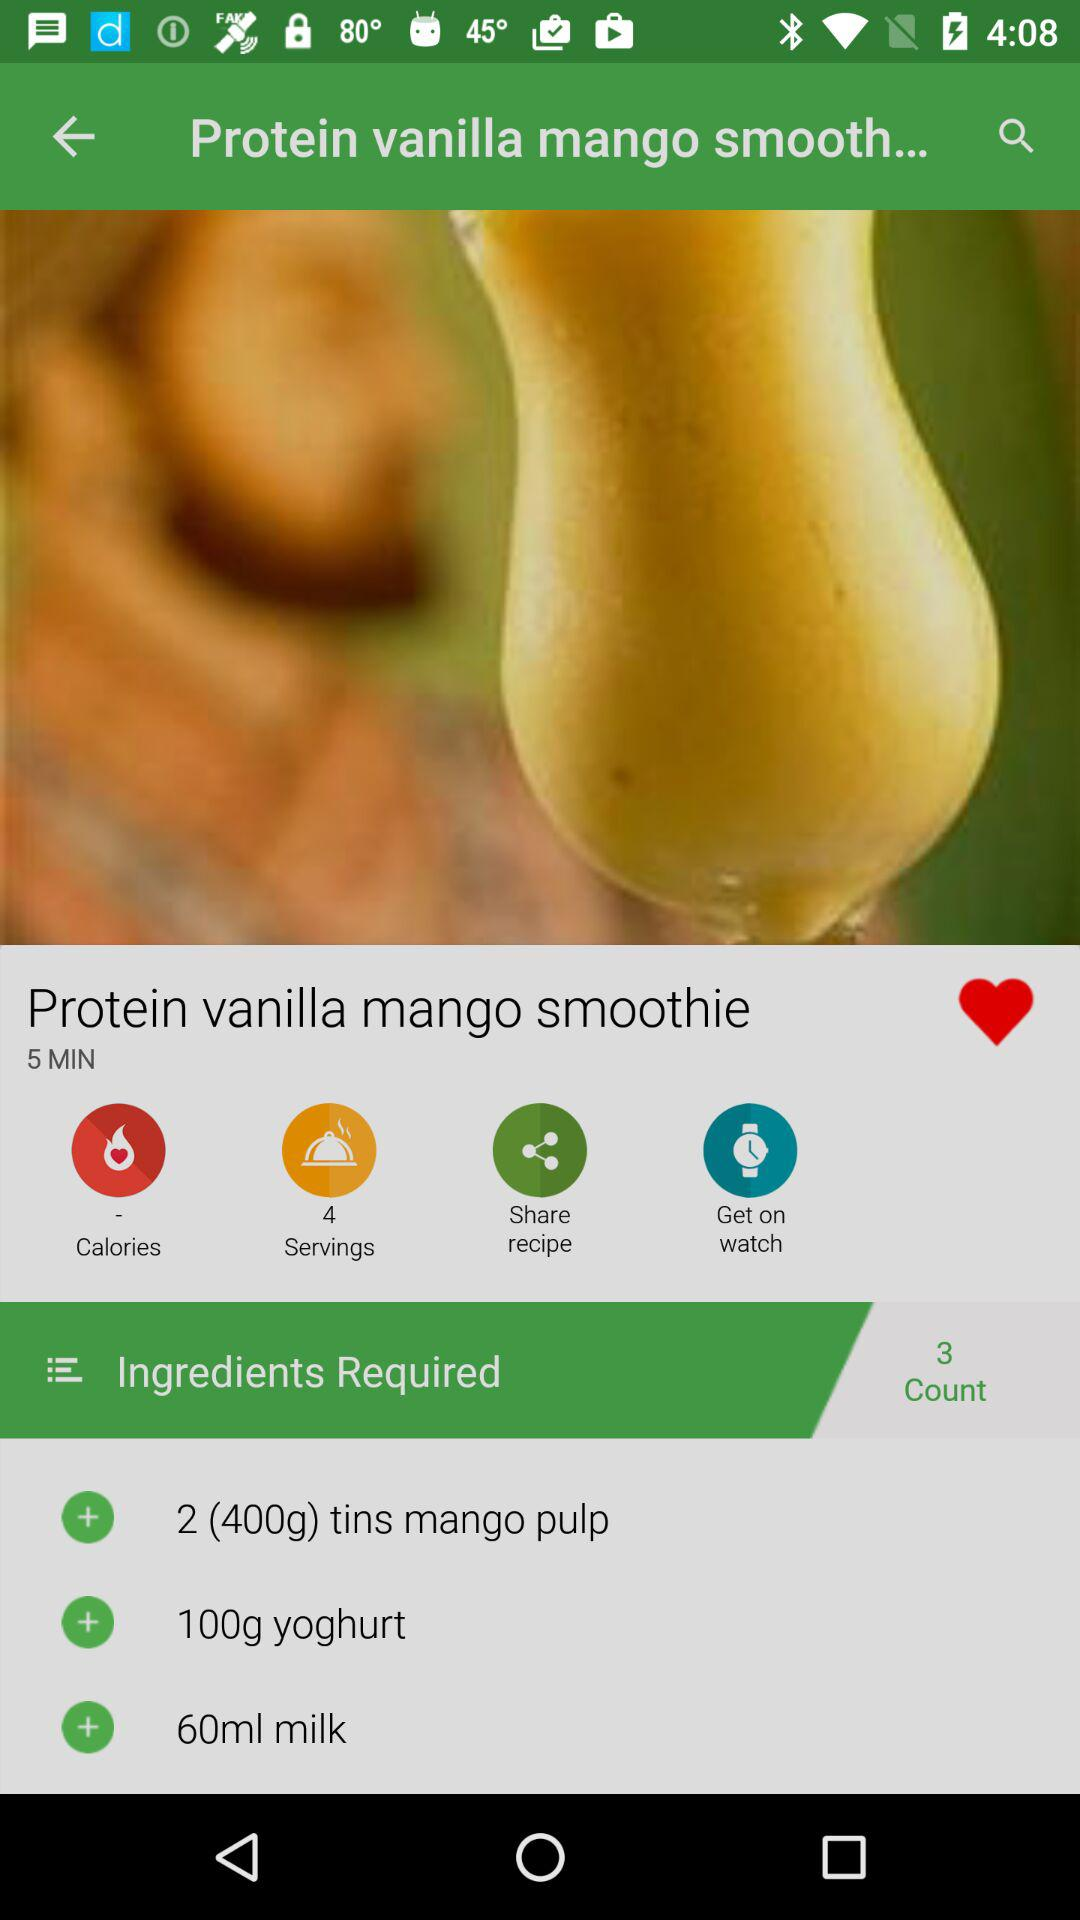How many servings does the recipe make?
Answer the question using a single word or phrase. 4 